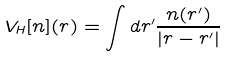<formula> <loc_0><loc_0><loc_500><loc_500>V _ { H } [ n ] ( { r } ) = \int d { r } ^ { \prime } \frac { n ( { r } ^ { \prime } ) } { | { r } - { r } ^ { \prime } | }</formula> 